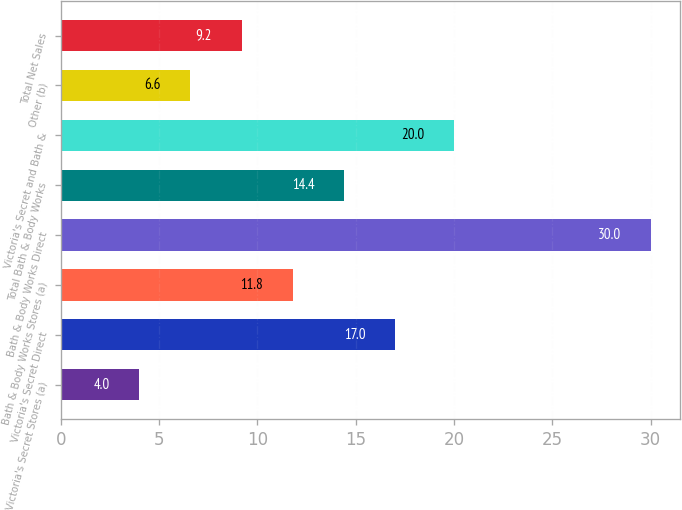Convert chart. <chart><loc_0><loc_0><loc_500><loc_500><bar_chart><fcel>Victoria's Secret Stores (a)<fcel>Victoria's Secret Direct<fcel>Bath & Body Works Stores (a)<fcel>Bath & Body Works Direct<fcel>Total Bath & Body Works<fcel>Victoria's Secret and Bath &<fcel>Other (b)<fcel>Total Net Sales<nl><fcel>4<fcel>17<fcel>11.8<fcel>30<fcel>14.4<fcel>20<fcel>6.6<fcel>9.2<nl></chart> 